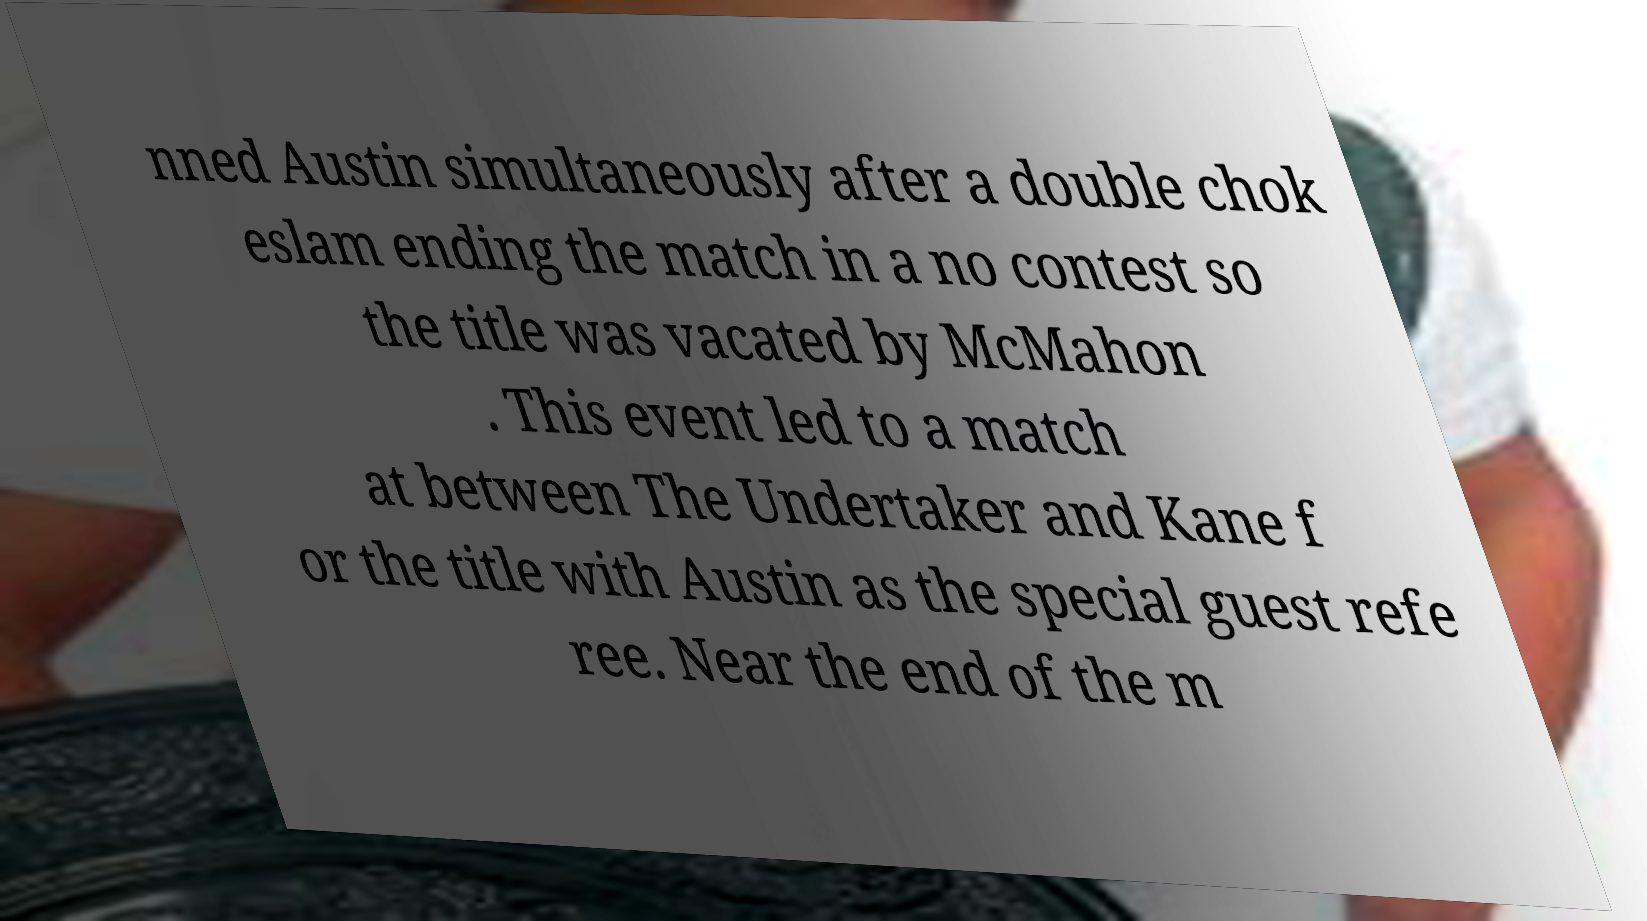Could you extract and type out the text from this image? nned Austin simultaneously after a double chok eslam ending the match in a no contest so the title was vacated by McMahon . This event led to a match at between The Undertaker and Kane f or the title with Austin as the special guest refe ree. Near the end of the m 